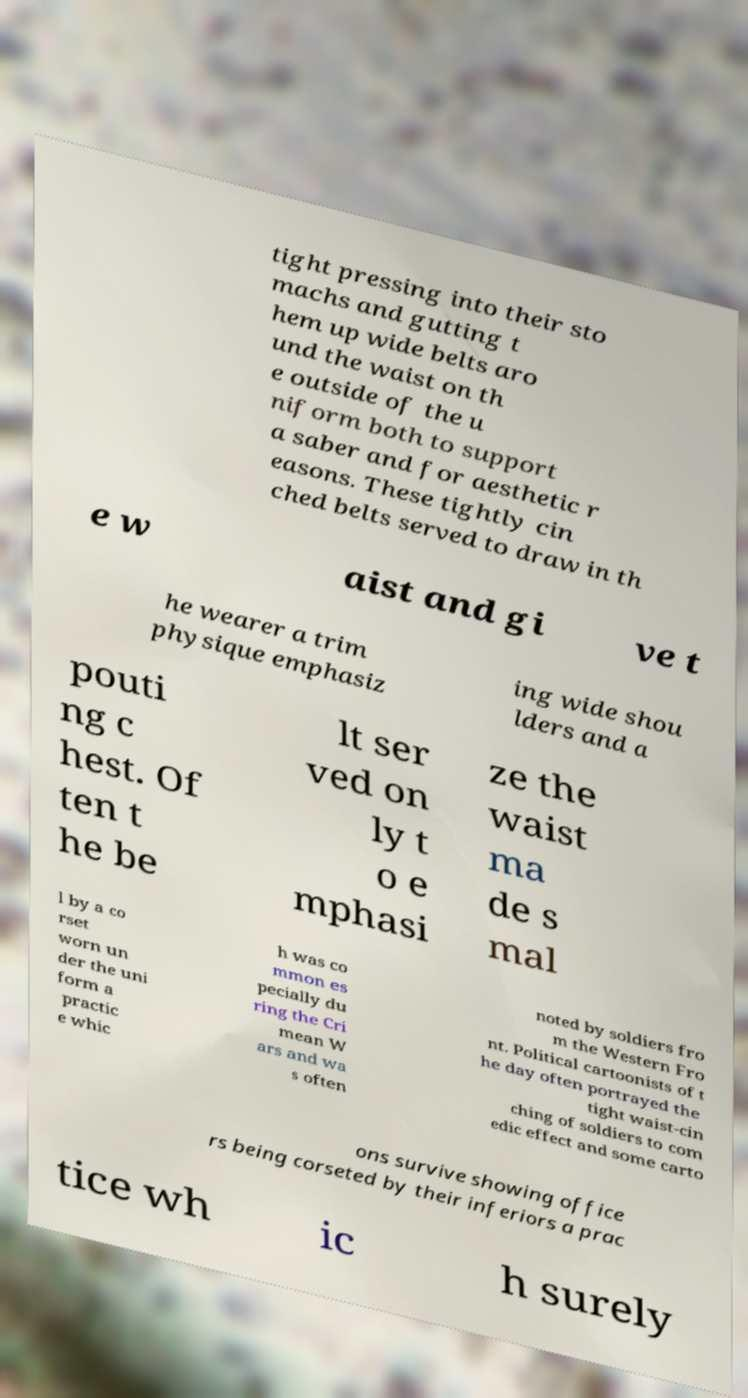There's text embedded in this image that I need extracted. Can you transcribe it verbatim? tight pressing into their sto machs and gutting t hem up wide belts aro und the waist on th e outside of the u niform both to support a saber and for aesthetic r easons. These tightly cin ched belts served to draw in th e w aist and gi ve t he wearer a trim physique emphasiz ing wide shou lders and a pouti ng c hest. Of ten t he be lt ser ved on ly t o e mphasi ze the waist ma de s mal l by a co rset worn un der the uni form a practic e whic h was co mmon es pecially du ring the Cri mean W ars and wa s often noted by soldiers fro m the Western Fro nt. Political cartoonists of t he day often portrayed the tight waist-cin ching of soldiers to com edic effect and some carto ons survive showing office rs being corseted by their inferiors a prac tice wh ic h surely 